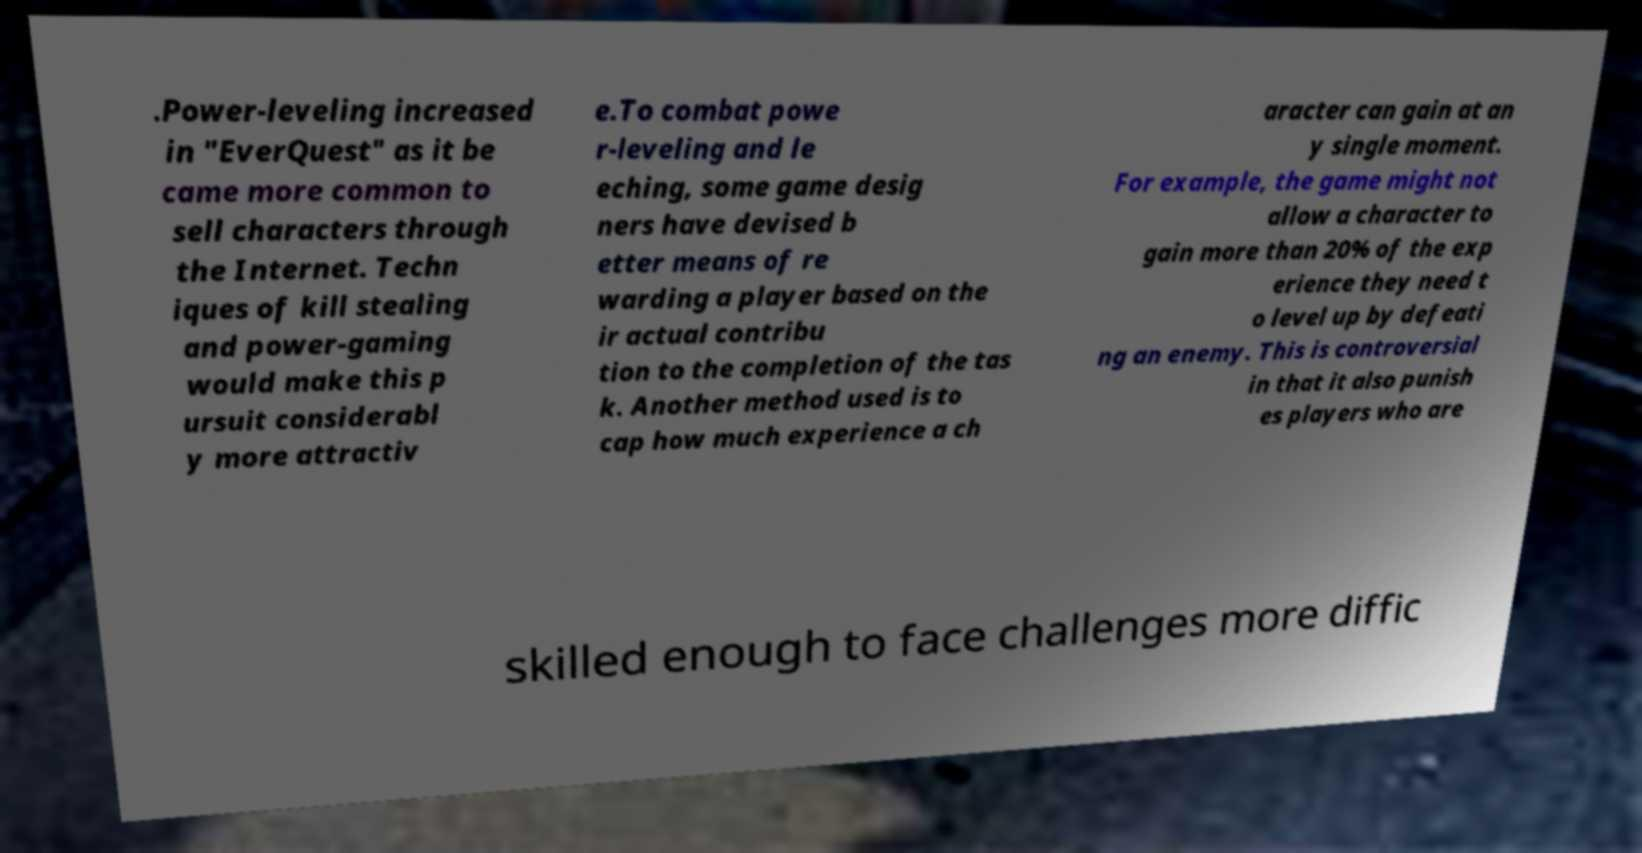Could you extract and type out the text from this image? .Power-leveling increased in "EverQuest" as it be came more common to sell characters through the Internet. Techn iques of kill stealing and power-gaming would make this p ursuit considerabl y more attractiv e.To combat powe r-leveling and le eching, some game desig ners have devised b etter means of re warding a player based on the ir actual contribu tion to the completion of the tas k. Another method used is to cap how much experience a ch aracter can gain at an y single moment. For example, the game might not allow a character to gain more than 20% of the exp erience they need t o level up by defeati ng an enemy. This is controversial in that it also punish es players who are skilled enough to face challenges more diffic 